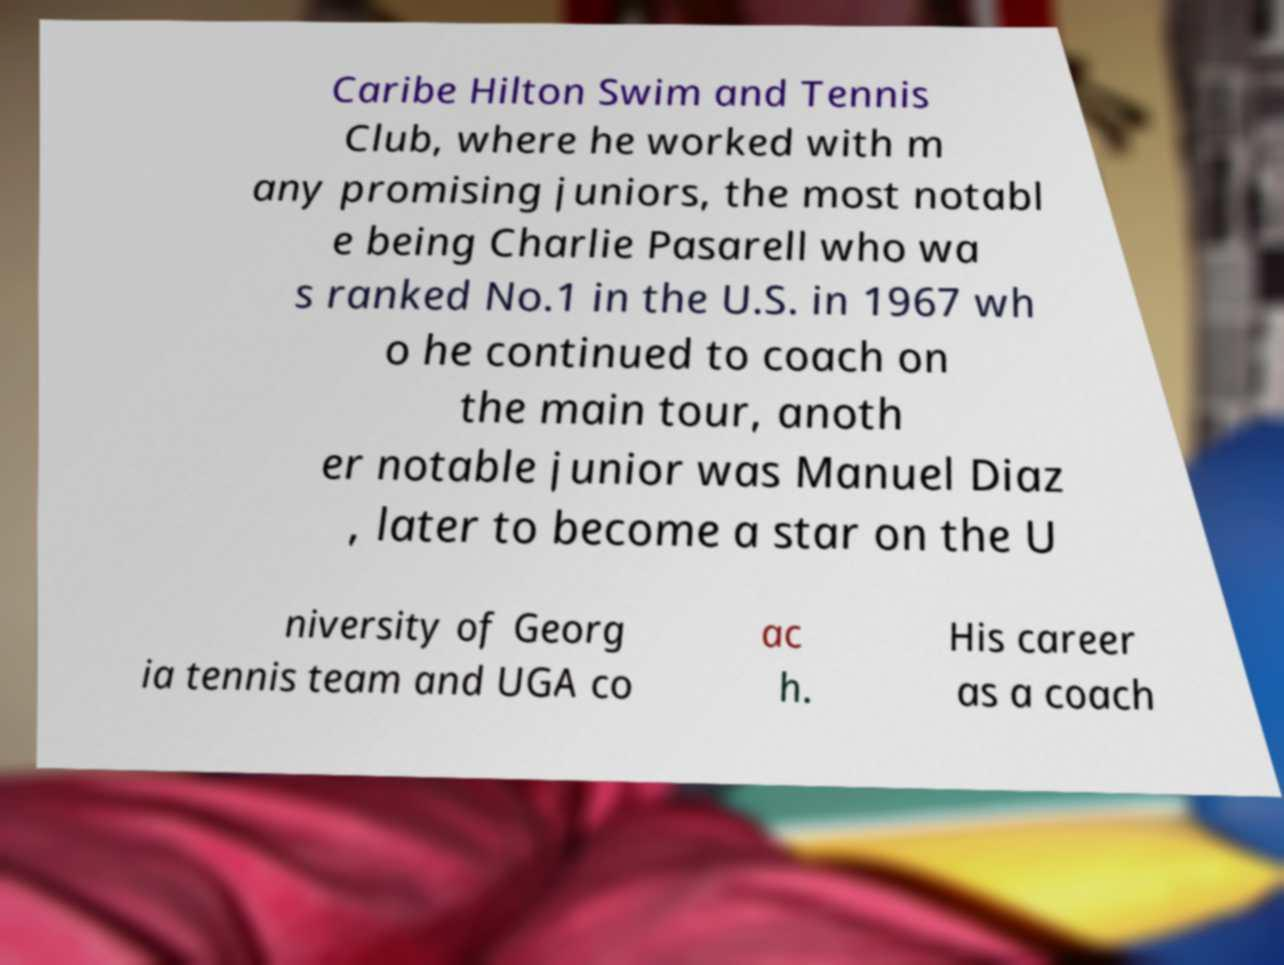Could you assist in decoding the text presented in this image and type it out clearly? Caribe Hilton Swim and Tennis Club, where he worked with m any promising juniors, the most notabl e being Charlie Pasarell who wa s ranked No.1 in the U.S. in 1967 wh o he continued to coach on the main tour, anoth er notable junior was Manuel Diaz , later to become a star on the U niversity of Georg ia tennis team and UGA co ac h. His career as a coach 